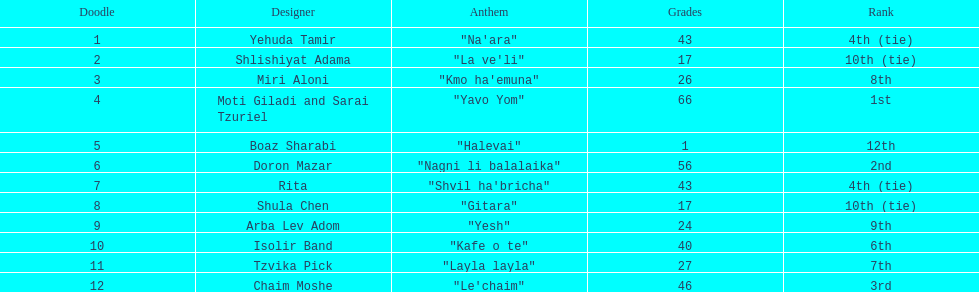What is the name of the first song listed on this chart? "Na'ara". 